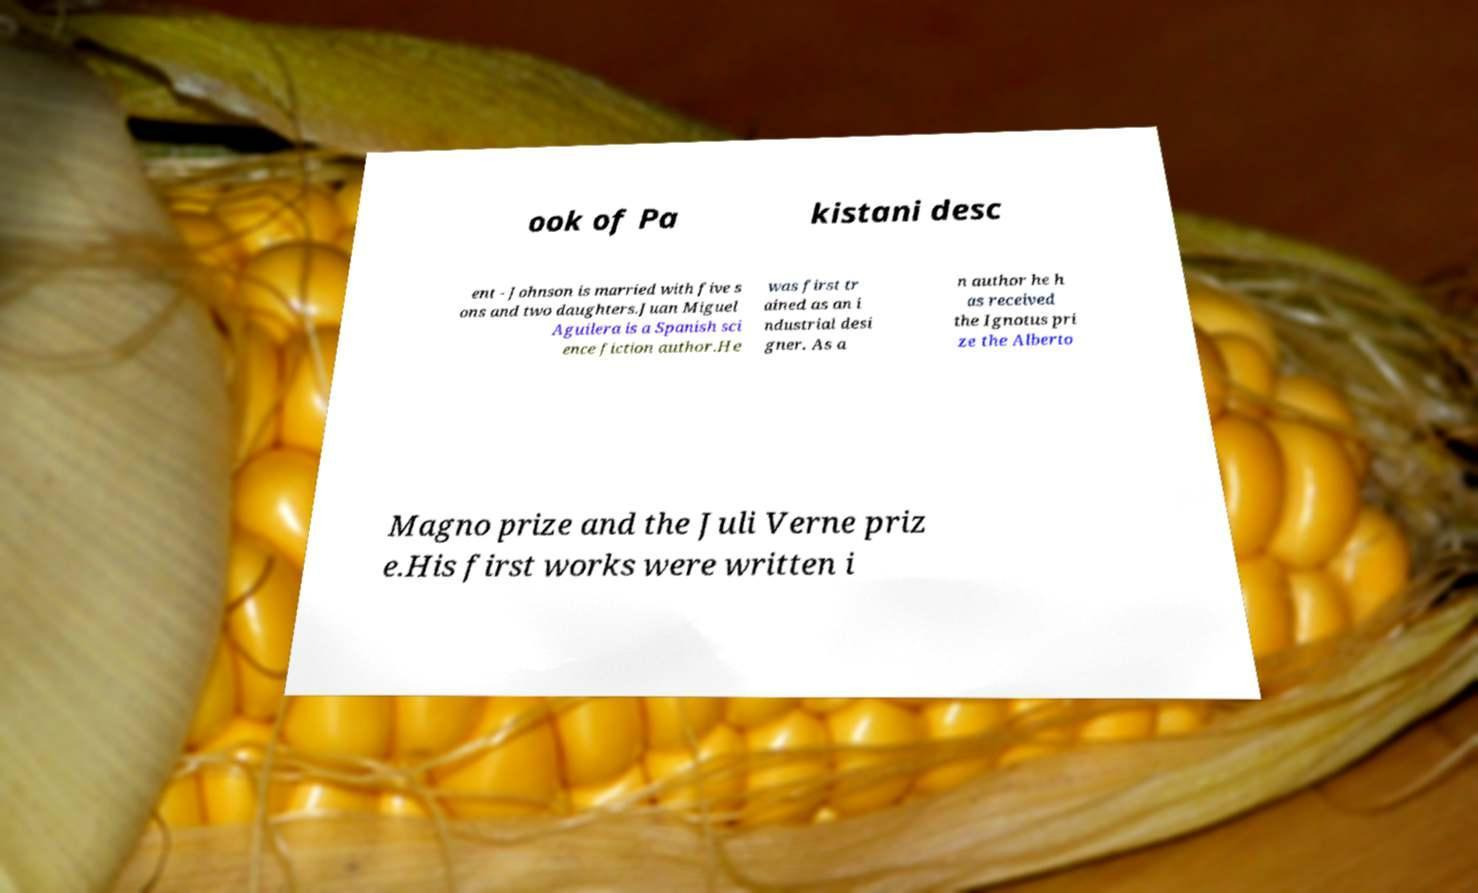I need the written content from this picture converted into text. Can you do that? ook of Pa kistani desc ent - Johnson is married with five s ons and two daughters.Juan Miguel Aguilera is a Spanish sci ence fiction author.He was first tr ained as an i ndustrial desi gner. As a n author he h as received the Ignotus pri ze the Alberto Magno prize and the Juli Verne priz e.His first works were written i 